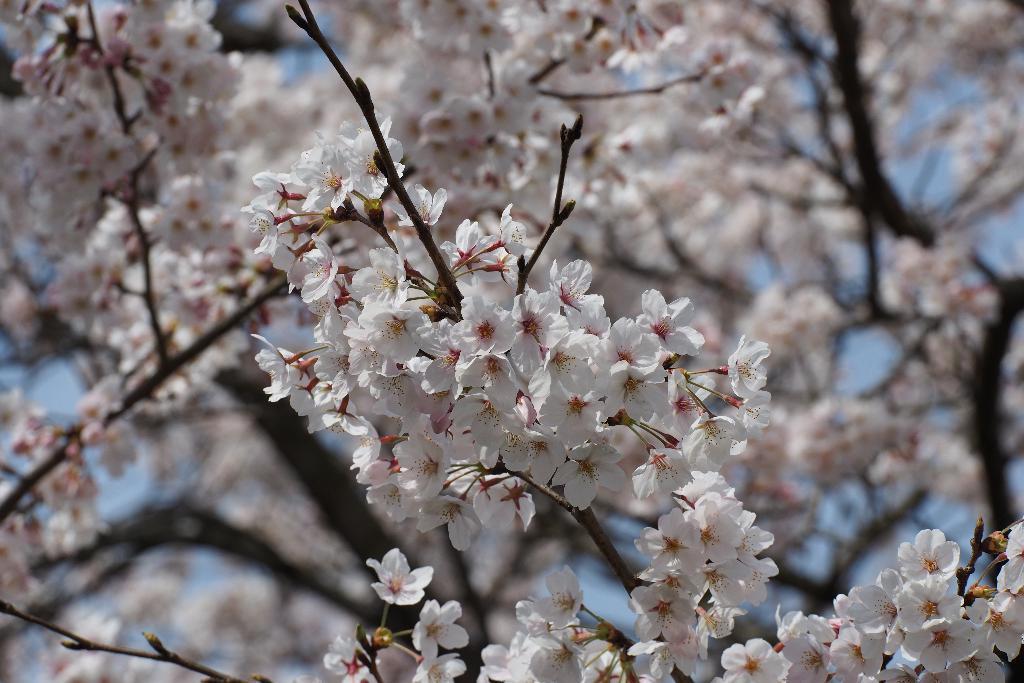Describe this image in one or two sentences. There is a tree which is having white color flowers. In the background, there is sky. 